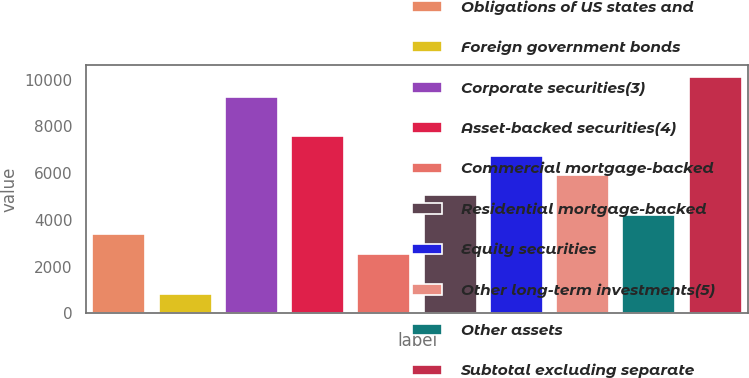Convert chart. <chart><loc_0><loc_0><loc_500><loc_500><bar_chart><fcel>Obligations of US states and<fcel>Foreign government bonds<fcel>Corporate securities(3)<fcel>Asset-backed securities(4)<fcel>Commercial mortgage-backed<fcel>Residential mortgage-backed<fcel>Equity securities<fcel>Other long-term investments(5)<fcel>Other assets<fcel>Subtotal excluding separate<nl><fcel>3375.6<fcel>845.4<fcel>9279.4<fcel>7592.6<fcel>2532.2<fcel>5062.4<fcel>6749.2<fcel>5905.8<fcel>4219<fcel>10122.8<nl></chart> 